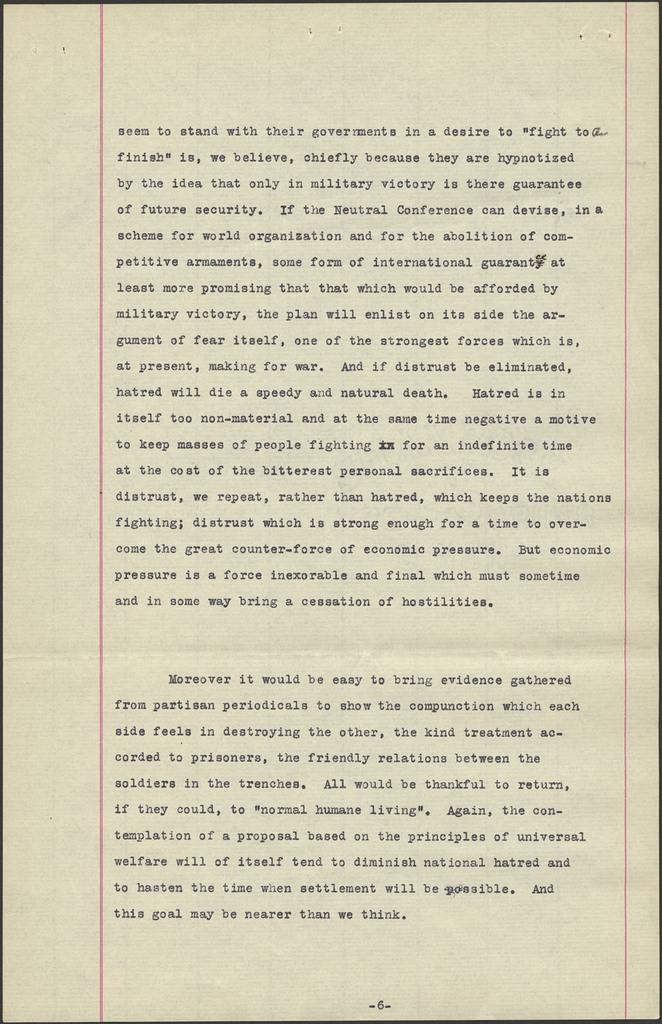<image>
Share a concise interpretation of the image provided. An odler excerpt from a book with the word think ending the page. 